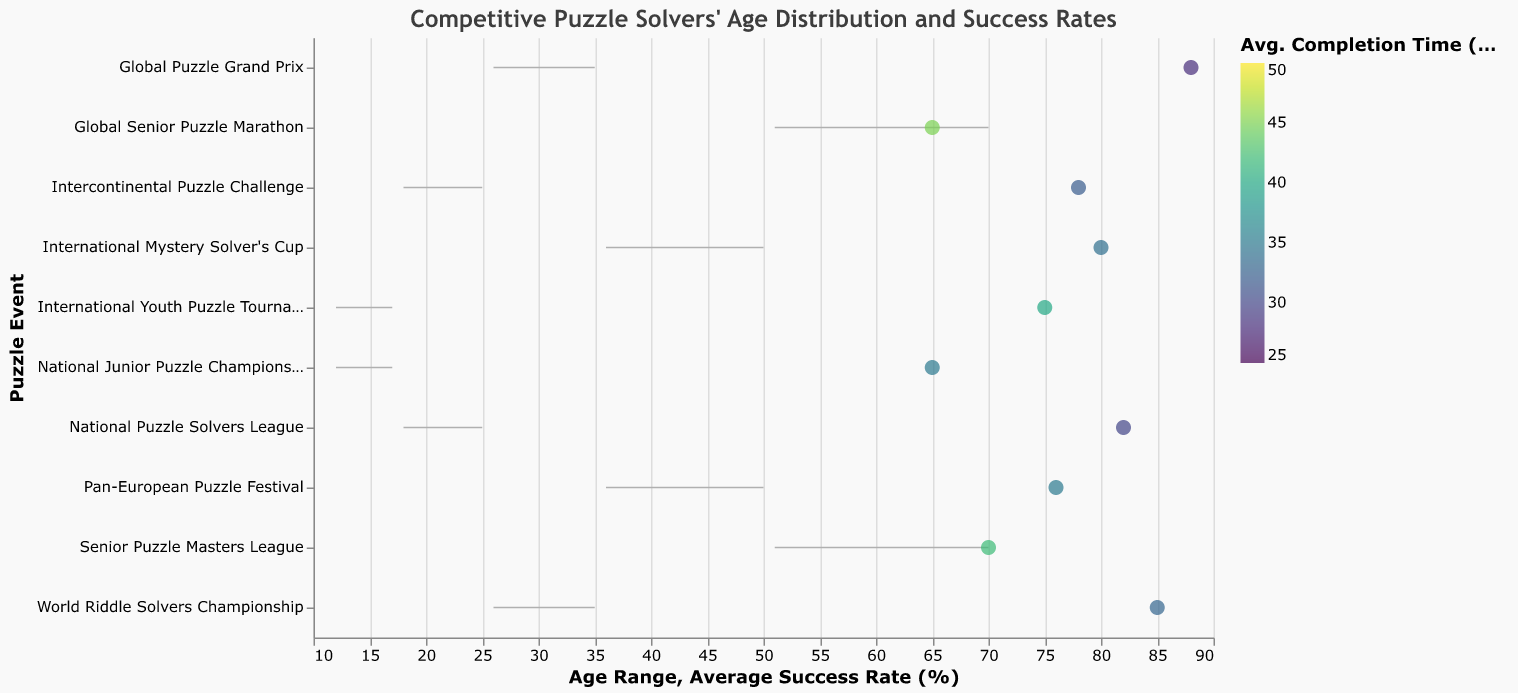What is the title of the figure? The title of the figure is displayed at the top, written in the font "Trebuchet MS," with a color code "#3d3d3d," which reads "Competitive Puzzle Solvers' Age Distribution and Success Rates."
Answer: Competitive Puzzle Solvers' Age Distribution and Success Rates Which age group has the highest average success rate? The age group with the highest average success rate has a rate of 88% in the Global Puzzle Grand Prix event.
Answer: 26_to_35 What is the range of ages for the "Senior Puzzle Masters League" event? The range of ages for the "Senior Puzzle Masters League" event extends from 51 to 70, as indicated by the "Min_Age" and "Max_Age" values.
Answer: 51 to 70 Which event has the shortest average completion time, and what is that time? The event with the shortest average completion time is the "Global Puzzle Grand Prix," which has an average completion time of 28 minutes.
Answer: Global Puzzle Grand Prix, 28 minutes How does the success rate of competitors in the "National Junior Puzzle Championship" compare to the "International Youth Puzzle Tournament"? The success rate for the "National Junior Puzzle Championship" is 65%, while the "International Youth Puzzle Tournament" is higher, with a success rate of 75%. A comparison shows that the "International Youth Puzzle Tournament" has a 10% higher success rate.
Answer: 10% higher What is the general trend in average success rates as the age groups increase? Generally, success rates tend to peak around the 26_to_35 age group and then decline. The under_18 group ranges from 65% to 75%, the 18_to_25 group is 78% to 82%, the 26_to_35 group is 85% to 88%, the 36_to_50 group is 76% to 80%, and the above_50 group is 65% to 70%.
Answer: Peaks at 26_to_35 and declines Which event has the highest average success rate among competitors aged 36 to 50? Competitors aged 36 to 50 have the highest average success rate in the "International Mystery Solver's Cup" event, which is 80%.
Answer: International Mystery Solver's Cup Compare the completion times for the "Global Puzzle Grand Prix" and "World Riddle Solvers Championship." Which one is shorter, and by how many minutes? The "Global Puzzle Grand Prix" has an average completion time of 28 minutes, whereas the "World Riddle Solvers Championship" has 33 minutes. The "Global Puzzle Grand Prix" is thus 5 minutes shorter.
Answer: Global Puzzle Grand Prix, 5 minutes less What is the average completion time for events where the average success rate exceeds 80%? Events with an average success rate exceeding 80% are the "National Puzzle Solvers League" (82%, 30 min), "Global Puzzle Grand Prix" (88%, 28 min), and "World Riddle Solvers Championship" (85%, 33 min). The average completion time is calculated as (30 + 28 + 33) / 3 = 30.33 minutes.
Answer: 30.33 minutes 